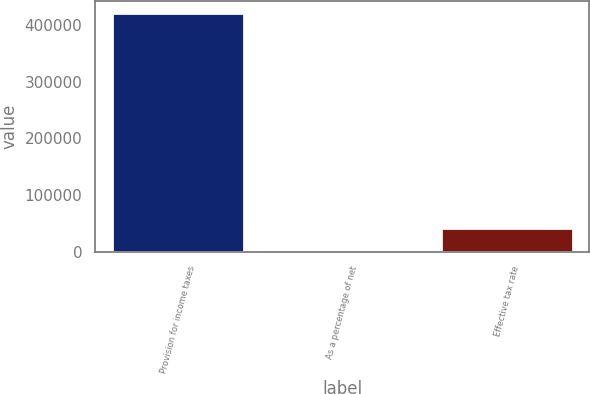<chart> <loc_0><loc_0><loc_500><loc_500><bar_chart><fcel>Provision for income taxes<fcel>As a percentage of net<fcel>Effective tax rate<nl><fcel>421418<fcel>7.1<fcel>42148.2<nl></chart> 